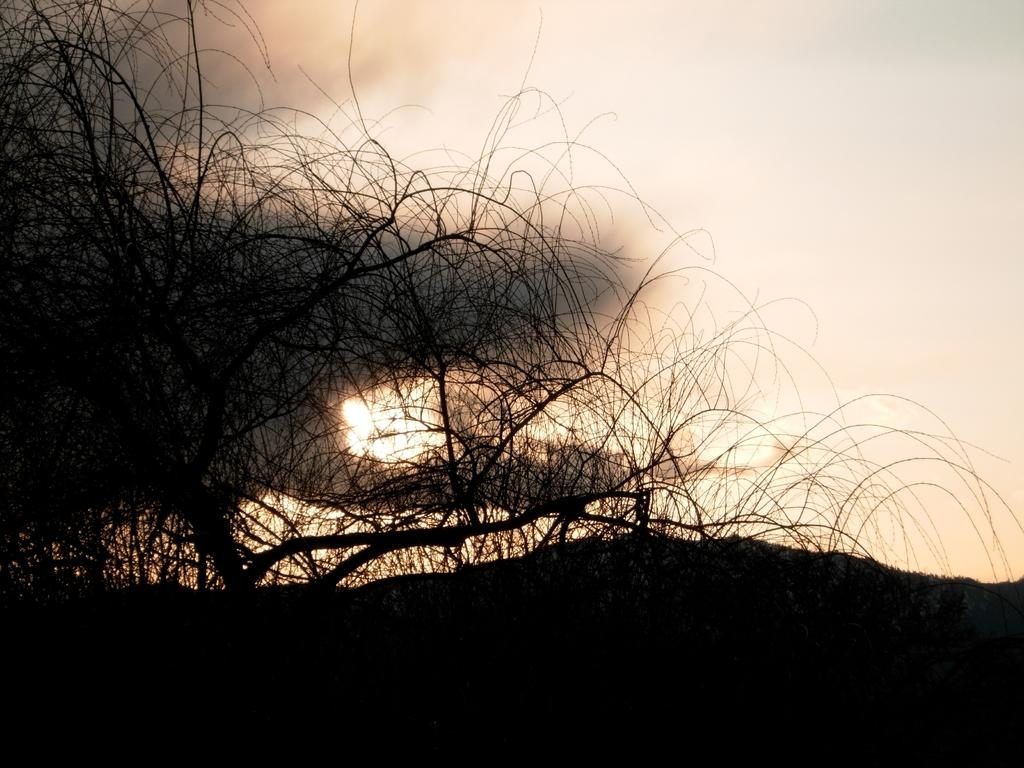What can be seen at the bottom of the image? The bottom of the image is dark. What is located on the left side of the image? There is a bare tree on the left side of the image. What is visible in the background of the image? Smoke and the sun are visible in the background of the image. Is there a pipe visible in the image? There is no pipe present in the image. Does the existence of the sun in the image prove the existence of life on other planets? The presence of the sun in the image does not provide any information about the existence of life on other planets. 